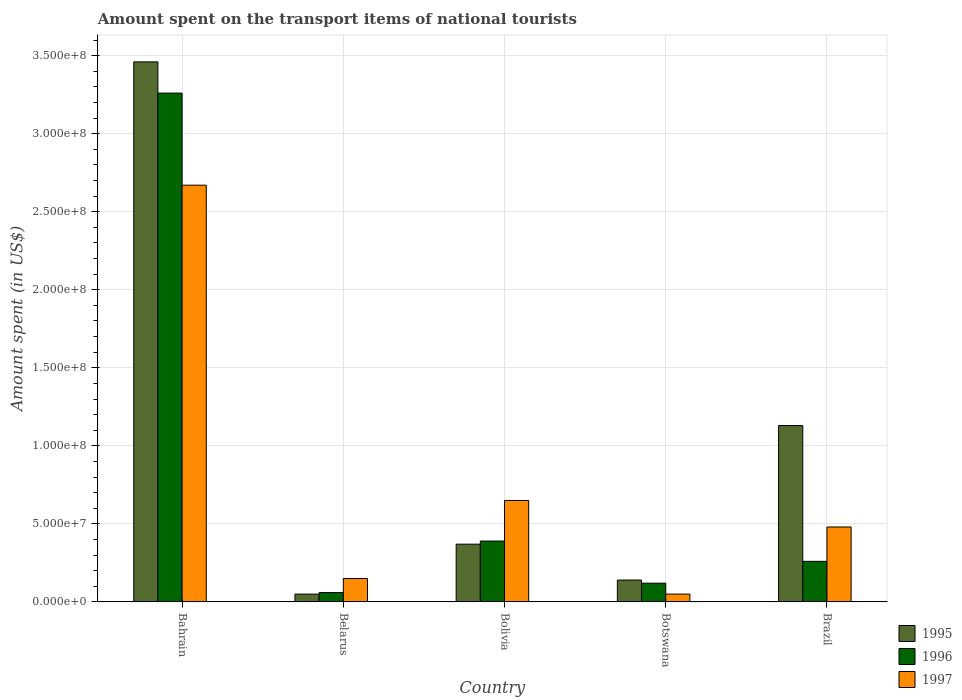How many different coloured bars are there?
Ensure brevity in your answer.  3. How many groups of bars are there?
Your answer should be very brief. 5. Are the number of bars per tick equal to the number of legend labels?
Keep it short and to the point. Yes. Are the number of bars on each tick of the X-axis equal?
Make the answer very short. Yes. How many bars are there on the 2nd tick from the left?
Your answer should be very brief. 3. What is the label of the 1st group of bars from the left?
Provide a succinct answer. Bahrain. What is the amount spent on the transport items of national tourists in 1997 in Bolivia?
Keep it short and to the point. 6.50e+07. Across all countries, what is the maximum amount spent on the transport items of national tourists in 1997?
Your answer should be compact. 2.67e+08. In which country was the amount spent on the transport items of national tourists in 1997 maximum?
Offer a terse response. Bahrain. In which country was the amount spent on the transport items of national tourists in 1995 minimum?
Provide a succinct answer. Belarus. What is the total amount spent on the transport items of national tourists in 1996 in the graph?
Make the answer very short. 4.09e+08. What is the difference between the amount spent on the transport items of national tourists in 1995 in Botswana and that in Brazil?
Offer a terse response. -9.90e+07. What is the difference between the amount spent on the transport items of national tourists in 1995 in Brazil and the amount spent on the transport items of national tourists in 1996 in Botswana?
Ensure brevity in your answer.  1.01e+08. What is the average amount spent on the transport items of national tourists in 1995 per country?
Offer a very short reply. 1.03e+08. What is the difference between the amount spent on the transport items of national tourists of/in 1997 and amount spent on the transport items of national tourists of/in 1995 in Bahrain?
Give a very brief answer. -7.90e+07. What is the ratio of the amount spent on the transport items of national tourists in 1995 in Bolivia to that in Botswana?
Your answer should be very brief. 2.64. Is the amount spent on the transport items of national tourists in 1995 in Bahrain less than that in Botswana?
Offer a terse response. No. What is the difference between the highest and the second highest amount spent on the transport items of national tourists in 1997?
Your response must be concise. 2.19e+08. What is the difference between the highest and the lowest amount spent on the transport items of national tourists in 1995?
Provide a short and direct response. 3.41e+08. What does the 3rd bar from the left in Brazil represents?
Provide a succinct answer. 1997. What does the 1st bar from the right in Bolivia represents?
Offer a terse response. 1997. Are the values on the major ticks of Y-axis written in scientific E-notation?
Your answer should be compact. Yes. Does the graph contain grids?
Make the answer very short. Yes. What is the title of the graph?
Offer a very short reply. Amount spent on the transport items of national tourists. What is the label or title of the Y-axis?
Offer a terse response. Amount spent (in US$). What is the Amount spent (in US$) in 1995 in Bahrain?
Provide a short and direct response. 3.46e+08. What is the Amount spent (in US$) in 1996 in Bahrain?
Give a very brief answer. 3.26e+08. What is the Amount spent (in US$) in 1997 in Bahrain?
Provide a short and direct response. 2.67e+08. What is the Amount spent (in US$) of 1996 in Belarus?
Your answer should be very brief. 6.00e+06. What is the Amount spent (in US$) in 1997 in Belarus?
Offer a terse response. 1.50e+07. What is the Amount spent (in US$) in 1995 in Bolivia?
Your response must be concise. 3.70e+07. What is the Amount spent (in US$) in 1996 in Bolivia?
Provide a short and direct response. 3.90e+07. What is the Amount spent (in US$) of 1997 in Bolivia?
Provide a short and direct response. 6.50e+07. What is the Amount spent (in US$) in 1995 in Botswana?
Ensure brevity in your answer.  1.40e+07. What is the Amount spent (in US$) in 1996 in Botswana?
Give a very brief answer. 1.20e+07. What is the Amount spent (in US$) of 1995 in Brazil?
Your answer should be very brief. 1.13e+08. What is the Amount spent (in US$) of 1996 in Brazil?
Your answer should be compact. 2.60e+07. What is the Amount spent (in US$) of 1997 in Brazil?
Provide a short and direct response. 4.80e+07. Across all countries, what is the maximum Amount spent (in US$) of 1995?
Your answer should be very brief. 3.46e+08. Across all countries, what is the maximum Amount spent (in US$) of 1996?
Provide a short and direct response. 3.26e+08. Across all countries, what is the maximum Amount spent (in US$) in 1997?
Provide a short and direct response. 2.67e+08. What is the total Amount spent (in US$) of 1995 in the graph?
Make the answer very short. 5.15e+08. What is the total Amount spent (in US$) in 1996 in the graph?
Make the answer very short. 4.09e+08. What is the total Amount spent (in US$) in 1997 in the graph?
Your answer should be compact. 4.00e+08. What is the difference between the Amount spent (in US$) of 1995 in Bahrain and that in Belarus?
Ensure brevity in your answer.  3.41e+08. What is the difference between the Amount spent (in US$) in 1996 in Bahrain and that in Belarus?
Offer a terse response. 3.20e+08. What is the difference between the Amount spent (in US$) in 1997 in Bahrain and that in Belarus?
Your answer should be compact. 2.52e+08. What is the difference between the Amount spent (in US$) in 1995 in Bahrain and that in Bolivia?
Make the answer very short. 3.09e+08. What is the difference between the Amount spent (in US$) of 1996 in Bahrain and that in Bolivia?
Your answer should be very brief. 2.87e+08. What is the difference between the Amount spent (in US$) in 1997 in Bahrain and that in Bolivia?
Provide a short and direct response. 2.02e+08. What is the difference between the Amount spent (in US$) of 1995 in Bahrain and that in Botswana?
Your answer should be very brief. 3.32e+08. What is the difference between the Amount spent (in US$) of 1996 in Bahrain and that in Botswana?
Keep it short and to the point. 3.14e+08. What is the difference between the Amount spent (in US$) of 1997 in Bahrain and that in Botswana?
Offer a very short reply. 2.62e+08. What is the difference between the Amount spent (in US$) in 1995 in Bahrain and that in Brazil?
Keep it short and to the point. 2.33e+08. What is the difference between the Amount spent (in US$) of 1996 in Bahrain and that in Brazil?
Offer a very short reply. 3.00e+08. What is the difference between the Amount spent (in US$) in 1997 in Bahrain and that in Brazil?
Offer a terse response. 2.19e+08. What is the difference between the Amount spent (in US$) of 1995 in Belarus and that in Bolivia?
Offer a very short reply. -3.20e+07. What is the difference between the Amount spent (in US$) in 1996 in Belarus and that in Bolivia?
Provide a short and direct response. -3.30e+07. What is the difference between the Amount spent (in US$) in 1997 in Belarus and that in Bolivia?
Keep it short and to the point. -5.00e+07. What is the difference between the Amount spent (in US$) in 1995 in Belarus and that in Botswana?
Your answer should be compact. -9.00e+06. What is the difference between the Amount spent (in US$) in 1996 in Belarus and that in Botswana?
Provide a succinct answer. -6.00e+06. What is the difference between the Amount spent (in US$) in 1995 in Belarus and that in Brazil?
Your answer should be very brief. -1.08e+08. What is the difference between the Amount spent (in US$) in 1996 in Belarus and that in Brazil?
Keep it short and to the point. -2.00e+07. What is the difference between the Amount spent (in US$) in 1997 in Belarus and that in Brazil?
Offer a very short reply. -3.30e+07. What is the difference between the Amount spent (in US$) in 1995 in Bolivia and that in Botswana?
Provide a succinct answer. 2.30e+07. What is the difference between the Amount spent (in US$) in 1996 in Bolivia and that in Botswana?
Your answer should be compact. 2.70e+07. What is the difference between the Amount spent (in US$) of 1997 in Bolivia and that in Botswana?
Make the answer very short. 6.00e+07. What is the difference between the Amount spent (in US$) in 1995 in Bolivia and that in Brazil?
Make the answer very short. -7.60e+07. What is the difference between the Amount spent (in US$) in 1996 in Bolivia and that in Brazil?
Provide a short and direct response. 1.30e+07. What is the difference between the Amount spent (in US$) of 1997 in Bolivia and that in Brazil?
Your answer should be very brief. 1.70e+07. What is the difference between the Amount spent (in US$) of 1995 in Botswana and that in Brazil?
Give a very brief answer. -9.90e+07. What is the difference between the Amount spent (in US$) of 1996 in Botswana and that in Brazil?
Your answer should be very brief. -1.40e+07. What is the difference between the Amount spent (in US$) of 1997 in Botswana and that in Brazil?
Ensure brevity in your answer.  -4.30e+07. What is the difference between the Amount spent (in US$) in 1995 in Bahrain and the Amount spent (in US$) in 1996 in Belarus?
Your answer should be compact. 3.40e+08. What is the difference between the Amount spent (in US$) of 1995 in Bahrain and the Amount spent (in US$) of 1997 in Belarus?
Your answer should be compact. 3.31e+08. What is the difference between the Amount spent (in US$) in 1996 in Bahrain and the Amount spent (in US$) in 1997 in Belarus?
Your response must be concise. 3.11e+08. What is the difference between the Amount spent (in US$) of 1995 in Bahrain and the Amount spent (in US$) of 1996 in Bolivia?
Offer a terse response. 3.07e+08. What is the difference between the Amount spent (in US$) in 1995 in Bahrain and the Amount spent (in US$) in 1997 in Bolivia?
Your response must be concise. 2.81e+08. What is the difference between the Amount spent (in US$) of 1996 in Bahrain and the Amount spent (in US$) of 1997 in Bolivia?
Provide a succinct answer. 2.61e+08. What is the difference between the Amount spent (in US$) in 1995 in Bahrain and the Amount spent (in US$) in 1996 in Botswana?
Offer a very short reply. 3.34e+08. What is the difference between the Amount spent (in US$) of 1995 in Bahrain and the Amount spent (in US$) of 1997 in Botswana?
Offer a very short reply. 3.41e+08. What is the difference between the Amount spent (in US$) of 1996 in Bahrain and the Amount spent (in US$) of 1997 in Botswana?
Your answer should be compact. 3.21e+08. What is the difference between the Amount spent (in US$) in 1995 in Bahrain and the Amount spent (in US$) in 1996 in Brazil?
Offer a terse response. 3.20e+08. What is the difference between the Amount spent (in US$) of 1995 in Bahrain and the Amount spent (in US$) of 1997 in Brazil?
Your answer should be very brief. 2.98e+08. What is the difference between the Amount spent (in US$) of 1996 in Bahrain and the Amount spent (in US$) of 1997 in Brazil?
Give a very brief answer. 2.78e+08. What is the difference between the Amount spent (in US$) in 1995 in Belarus and the Amount spent (in US$) in 1996 in Bolivia?
Your answer should be compact. -3.40e+07. What is the difference between the Amount spent (in US$) of 1995 in Belarus and the Amount spent (in US$) of 1997 in Bolivia?
Your answer should be compact. -6.00e+07. What is the difference between the Amount spent (in US$) in 1996 in Belarus and the Amount spent (in US$) in 1997 in Bolivia?
Ensure brevity in your answer.  -5.90e+07. What is the difference between the Amount spent (in US$) in 1995 in Belarus and the Amount spent (in US$) in 1996 in Botswana?
Your answer should be very brief. -7.00e+06. What is the difference between the Amount spent (in US$) in 1996 in Belarus and the Amount spent (in US$) in 1997 in Botswana?
Give a very brief answer. 1.00e+06. What is the difference between the Amount spent (in US$) in 1995 in Belarus and the Amount spent (in US$) in 1996 in Brazil?
Your answer should be compact. -2.10e+07. What is the difference between the Amount spent (in US$) in 1995 in Belarus and the Amount spent (in US$) in 1997 in Brazil?
Your answer should be compact. -4.30e+07. What is the difference between the Amount spent (in US$) in 1996 in Belarus and the Amount spent (in US$) in 1997 in Brazil?
Your response must be concise. -4.20e+07. What is the difference between the Amount spent (in US$) in 1995 in Bolivia and the Amount spent (in US$) in 1996 in Botswana?
Offer a very short reply. 2.50e+07. What is the difference between the Amount spent (in US$) in 1995 in Bolivia and the Amount spent (in US$) in 1997 in Botswana?
Ensure brevity in your answer.  3.20e+07. What is the difference between the Amount spent (in US$) in 1996 in Bolivia and the Amount spent (in US$) in 1997 in Botswana?
Give a very brief answer. 3.40e+07. What is the difference between the Amount spent (in US$) in 1995 in Bolivia and the Amount spent (in US$) in 1996 in Brazil?
Your response must be concise. 1.10e+07. What is the difference between the Amount spent (in US$) in 1995 in Bolivia and the Amount spent (in US$) in 1997 in Brazil?
Offer a very short reply. -1.10e+07. What is the difference between the Amount spent (in US$) of 1996 in Bolivia and the Amount spent (in US$) of 1997 in Brazil?
Provide a succinct answer. -9.00e+06. What is the difference between the Amount spent (in US$) in 1995 in Botswana and the Amount spent (in US$) in 1996 in Brazil?
Make the answer very short. -1.20e+07. What is the difference between the Amount spent (in US$) in 1995 in Botswana and the Amount spent (in US$) in 1997 in Brazil?
Make the answer very short. -3.40e+07. What is the difference between the Amount spent (in US$) of 1996 in Botswana and the Amount spent (in US$) of 1997 in Brazil?
Ensure brevity in your answer.  -3.60e+07. What is the average Amount spent (in US$) of 1995 per country?
Offer a very short reply. 1.03e+08. What is the average Amount spent (in US$) in 1996 per country?
Offer a terse response. 8.18e+07. What is the average Amount spent (in US$) in 1997 per country?
Offer a very short reply. 8.00e+07. What is the difference between the Amount spent (in US$) of 1995 and Amount spent (in US$) of 1996 in Bahrain?
Ensure brevity in your answer.  2.00e+07. What is the difference between the Amount spent (in US$) of 1995 and Amount spent (in US$) of 1997 in Bahrain?
Give a very brief answer. 7.90e+07. What is the difference between the Amount spent (in US$) of 1996 and Amount spent (in US$) of 1997 in Bahrain?
Provide a short and direct response. 5.90e+07. What is the difference between the Amount spent (in US$) of 1995 and Amount spent (in US$) of 1997 in Belarus?
Offer a very short reply. -1.00e+07. What is the difference between the Amount spent (in US$) of 1996 and Amount spent (in US$) of 1997 in Belarus?
Make the answer very short. -9.00e+06. What is the difference between the Amount spent (in US$) of 1995 and Amount spent (in US$) of 1996 in Bolivia?
Offer a very short reply. -2.00e+06. What is the difference between the Amount spent (in US$) in 1995 and Amount spent (in US$) in 1997 in Bolivia?
Ensure brevity in your answer.  -2.80e+07. What is the difference between the Amount spent (in US$) of 1996 and Amount spent (in US$) of 1997 in Bolivia?
Offer a terse response. -2.60e+07. What is the difference between the Amount spent (in US$) of 1995 and Amount spent (in US$) of 1996 in Botswana?
Provide a short and direct response. 2.00e+06. What is the difference between the Amount spent (in US$) of 1995 and Amount spent (in US$) of 1997 in Botswana?
Keep it short and to the point. 9.00e+06. What is the difference between the Amount spent (in US$) of 1995 and Amount spent (in US$) of 1996 in Brazil?
Give a very brief answer. 8.70e+07. What is the difference between the Amount spent (in US$) of 1995 and Amount spent (in US$) of 1997 in Brazil?
Give a very brief answer. 6.50e+07. What is the difference between the Amount spent (in US$) of 1996 and Amount spent (in US$) of 1997 in Brazil?
Offer a very short reply. -2.20e+07. What is the ratio of the Amount spent (in US$) of 1995 in Bahrain to that in Belarus?
Make the answer very short. 69.2. What is the ratio of the Amount spent (in US$) of 1996 in Bahrain to that in Belarus?
Your response must be concise. 54.33. What is the ratio of the Amount spent (in US$) in 1995 in Bahrain to that in Bolivia?
Your answer should be very brief. 9.35. What is the ratio of the Amount spent (in US$) in 1996 in Bahrain to that in Bolivia?
Ensure brevity in your answer.  8.36. What is the ratio of the Amount spent (in US$) in 1997 in Bahrain to that in Bolivia?
Offer a terse response. 4.11. What is the ratio of the Amount spent (in US$) of 1995 in Bahrain to that in Botswana?
Provide a short and direct response. 24.71. What is the ratio of the Amount spent (in US$) of 1996 in Bahrain to that in Botswana?
Make the answer very short. 27.17. What is the ratio of the Amount spent (in US$) of 1997 in Bahrain to that in Botswana?
Provide a succinct answer. 53.4. What is the ratio of the Amount spent (in US$) of 1995 in Bahrain to that in Brazil?
Your response must be concise. 3.06. What is the ratio of the Amount spent (in US$) of 1996 in Bahrain to that in Brazil?
Your answer should be very brief. 12.54. What is the ratio of the Amount spent (in US$) of 1997 in Bahrain to that in Brazil?
Make the answer very short. 5.56. What is the ratio of the Amount spent (in US$) in 1995 in Belarus to that in Bolivia?
Your answer should be compact. 0.14. What is the ratio of the Amount spent (in US$) in 1996 in Belarus to that in Bolivia?
Ensure brevity in your answer.  0.15. What is the ratio of the Amount spent (in US$) in 1997 in Belarus to that in Bolivia?
Your answer should be very brief. 0.23. What is the ratio of the Amount spent (in US$) of 1995 in Belarus to that in Botswana?
Your answer should be compact. 0.36. What is the ratio of the Amount spent (in US$) of 1995 in Belarus to that in Brazil?
Provide a short and direct response. 0.04. What is the ratio of the Amount spent (in US$) in 1996 in Belarus to that in Brazil?
Keep it short and to the point. 0.23. What is the ratio of the Amount spent (in US$) of 1997 in Belarus to that in Brazil?
Provide a short and direct response. 0.31. What is the ratio of the Amount spent (in US$) of 1995 in Bolivia to that in Botswana?
Keep it short and to the point. 2.64. What is the ratio of the Amount spent (in US$) of 1996 in Bolivia to that in Botswana?
Your answer should be very brief. 3.25. What is the ratio of the Amount spent (in US$) of 1997 in Bolivia to that in Botswana?
Give a very brief answer. 13. What is the ratio of the Amount spent (in US$) of 1995 in Bolivia to that in Brazil?
Give a very brief answer. 0.33. What is the ratio of the Amount spent (in US$) in 1996 in Bolivia to that in Brazil?
Provide a short and direct response. 1.5. What is the ratio of the Amount spent (in US$) of 1997 in Bolivia to that in Brazil?
Your answer should be very brief. 1.35. What is the ratio of the Amount spent (in US$) of 1995 in Botswana to that in Brazil?
Make the answer very short. 0.12. What is the ratio of the Amount spent (in US$) of 1996 in Botswana to that in Brazil?
Offer a terse response. 0.46. What is the ratio of the Amount spent (in US$) in 1997 in Botswana to that in Brazil?
Ensure brevity in your answer.  0.1. What is the difference between the highest and the second highest Amount spent (in US$) of 1995?
Ensure brevity in your answer.  2.33e+08. What is the difference between the highest and the second highest Amount spent (in US$) of 1996?
Your response must be concise. 2.87e+08. What is the difference between the highest and the second highest Amount spent (in US$) in 1997?
Give a very brief answer. 2.02e+08. What is the difference between the highest and the lowest Amount spent (in US$) in 1995?
Ensure brevity in your answer.  3.41e+08. What is the difference between the highest and the lowest Amount spent (in US$) in 1996?
Your answer should be compact. 3.20e+08. What is the difference between the highest and the lowest Amount spent (in US$) of 1997?
Your answer should be very brief. 2.62e+08. 